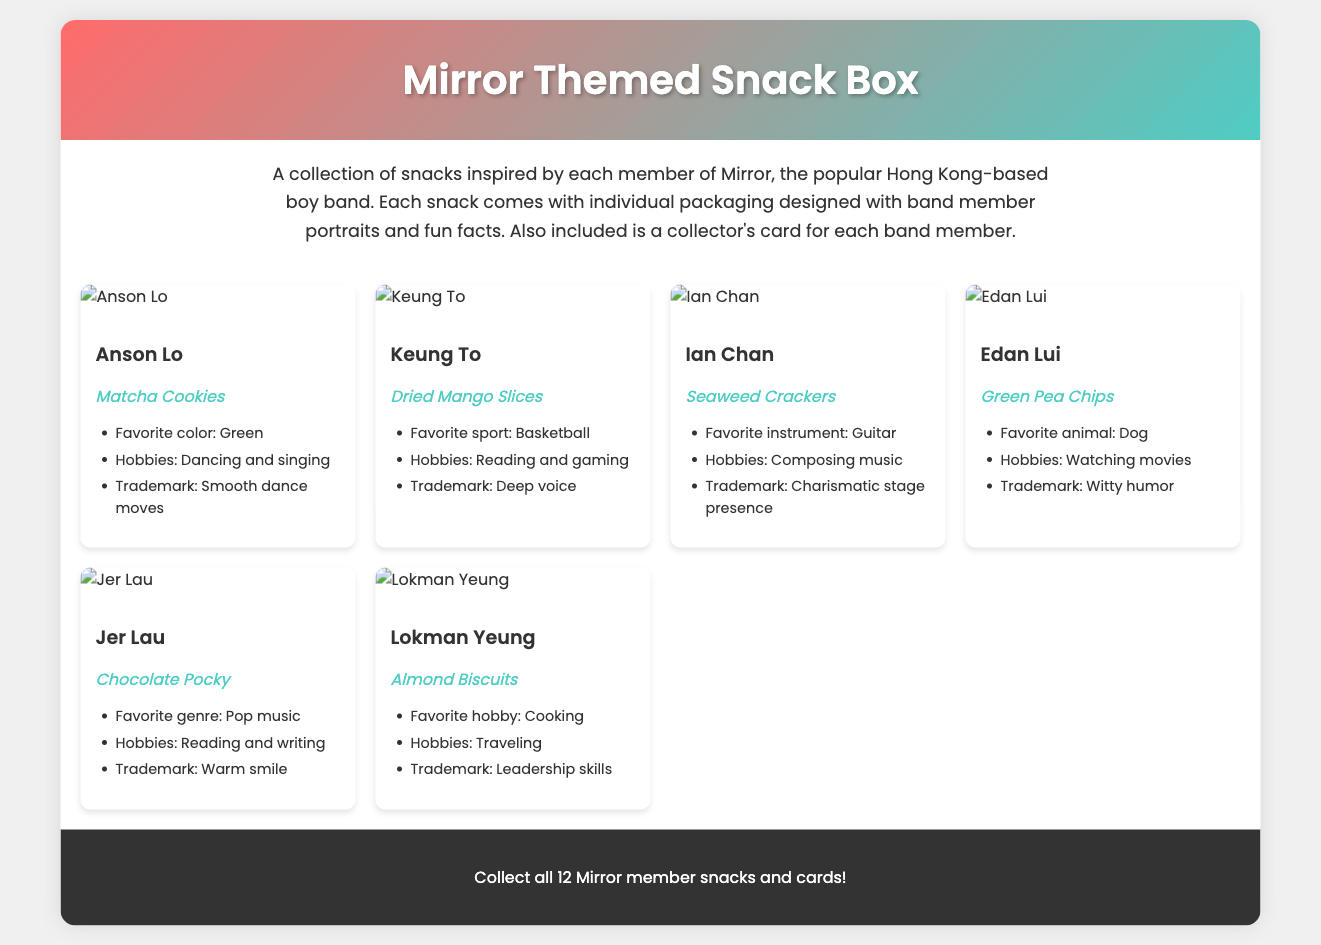What is the name of the snack associated with Anson Lo? Anson Lo is associated with Matcha Cookies, which is listed under his member information.
Answer: Matcha Cookies What is Keung To's favorite sport? The favorite sport listed for Keung To is Basketball, which is stated in the fun facts section.
Answer: Basketball Who has a trademark of a warm smile? The fun fact section for Jer Lau mentions that his trademark is a warm smile, indicating that this is a notable characteristic.
Answer: Jer Lau How many members are featured in the snack box? The document mentions the collection includes snacks inspired by each member of Mirror, identifying a total of six members represented.
Answer: 6 Which member's favorite animal is a dog? The fun facts for Edan Lui state that his favorite animal is a dog, providing specific information about his personal preference.
Answer: Dog What type of packaging does each snack come in? Each snack features individual packaging designed with band member portraits and fun facts, emphasizing the unique presentation for each member.
Answer: Individual packaging with member portraits What type of product is described in the document? The document describes a themed snack box that includes snacks and collectible items related to the band Mirror.
Answer: Themed snack box What is included with each band member's snack? The description specifies that a collector's card for each band member comes along with their snack in the box.
Answer: Collector's card 